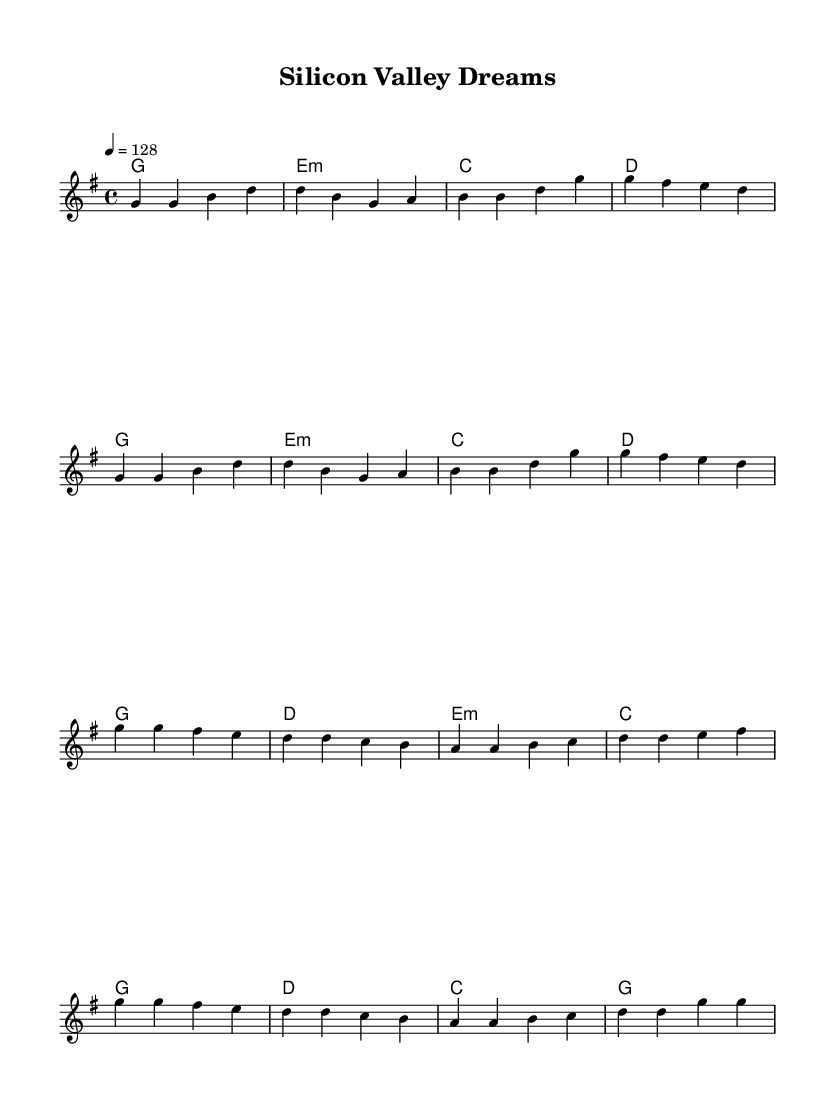What is the key signature of this music? The key signature is G major, which has one sharp (F#).
Answer: G major What is the time signature of the piece? The time signature is 4/4, indicating four beats per measure.
Answer: 4/4 What is the tempo marking of this piece? The tempo marking is a quarter note equals 128 beats per minute.
Answer: 128 How many measures are in the verse section? The verse section consists of eight measures, as counted from the melody.
Answer: 8 Which chord appears most frequently in the piece? The G chord appears frequently in both the verse and chorus sections, indicating a stable tonal center.
Answer: G What is the rhythmic feel of the melody in terms of beat emphasis? The melody emphasizes the first and third beats of each measure, common in upbeat pop tracks, creating a driving rhythm.
Answer: First and third beats How does the chorus differ from the verse in terms of dynamics? The chorus typically has a more energetic and uplifting dynamic, distinguishing itself from the softer, more reflective verse.
Answer: Energetic 